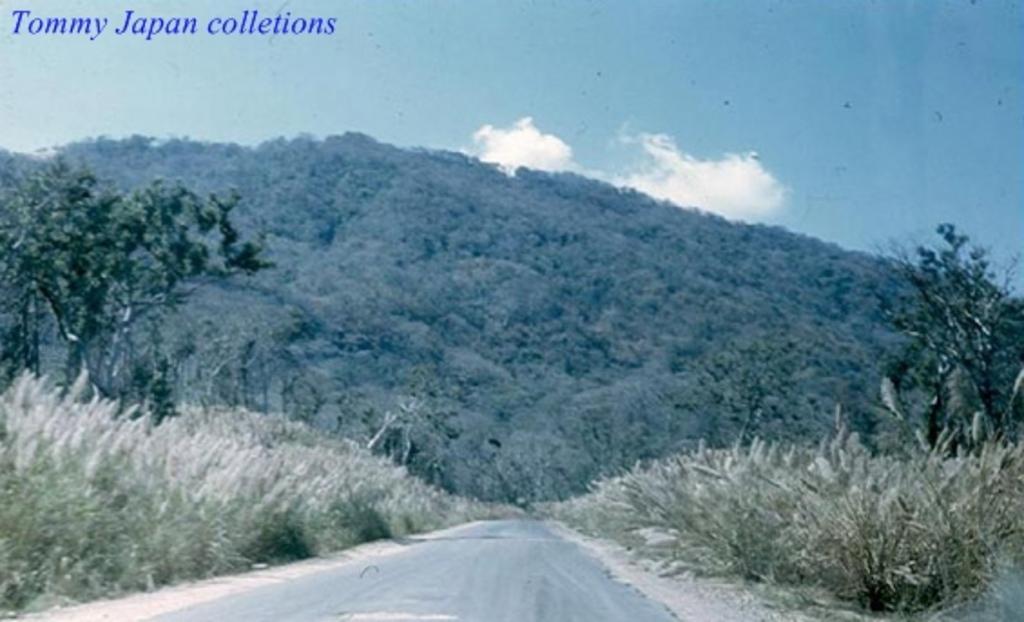In one or two sentences, can you explain what this image depicts? In this image there are trees. There is dry grass and the sky is cloudy. 